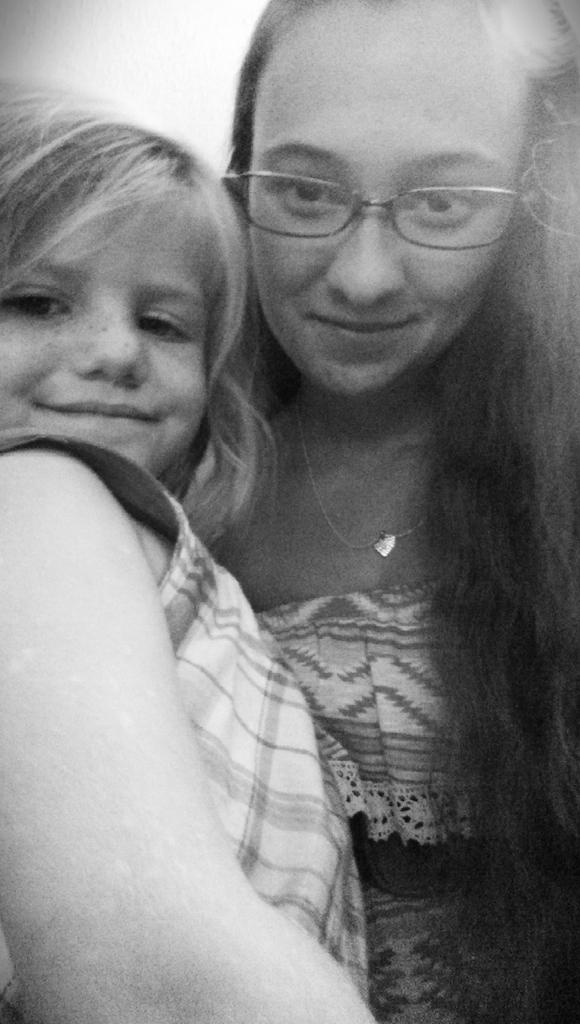How many people are in the image? There are two people in the image. What are the people wearing? Both people are wearing dresses. Can you describe any additional accessories worn by one of the people? One person is wearing goggles. What is the color scheme of the image? The image is black and white. What is the title of the book being read by the person in the image? There is no book or reading activity depicted in the image. How does the sun affect the appearance of the people in the image? The image is black and white, so the sun's effect on the appearance of the people cannot be determined. 